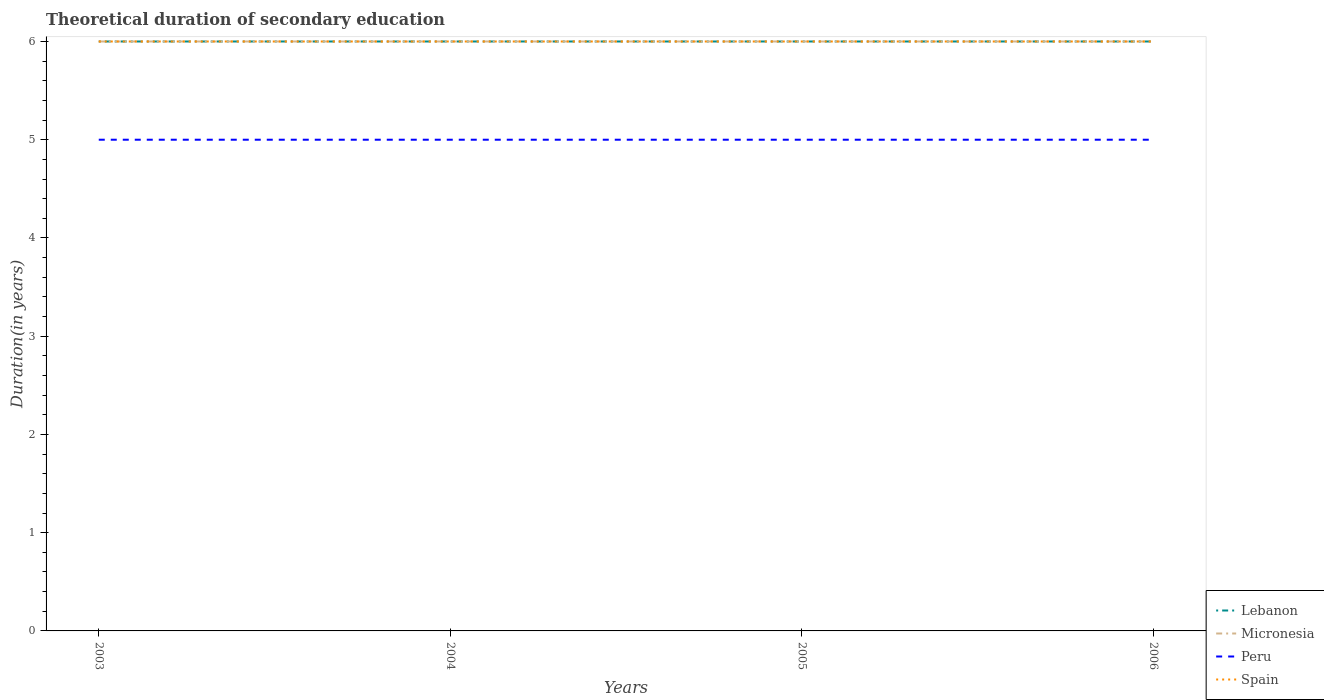Is the number of lines equal to the number of legend labels?
Provide a succinct answer. Yes. In which year was the total theoretical duration of secondary education in Spain maximum?
Your answer should be very brief. 2003. What is the difference between the highest and the lowest total theoretical duration of secondary education in Peru?
Your response must be concise. 0. Is the total theoretical duration of secondary education in Micronesia strictly greater than the total theoretical duration of secondary education in Lebanon over the years?
Offer a terse response. No. What is the difference between two consecutive major ticks on the Y-axis?
Offer a terse response. 1. Does the graph contain any zero values?
Give a very brief answer. No. What is the title of the graph?
Offer a very short reply. Theoretical duration of secondary education. What is the label or title of the X-axis?
Your answer should be very brief. Years. What is the label or title of the Y-axis?
Your answer should be very brief. Duration(in years). What is the Duration(in years) in Lebanon in 2003?
Ensure brevity in your answer.  6. What is the Duration(in years) in Micronesia in 2003?
Keep it short and to the point. 6. What is the Duration(in years) of Micronesia in 2004?
Keep it short and to the point. 6. What is the Duration(in years) in Spain in 2004?
Provide a short and direct response. 6. What is the Duration(in years) in Micronesia in 2005?
Your response must be concise. 6. What is the Duration(in years) of Peru in 2005?
Give a very brief answer. 5. What is the Duration(in years) in Spain in 2005?
Provide a succinct answer. 6. What is the Duration(in years) of Spain in 2006?
Keep it short and to the point. 6. Across all years, what is the maximum Duration(in years) of Lebanon?
Your answer should be compact. 6. Across all years, what is the maximum Duration(in years) of Spain?
Ensure brevity in your answer.  6. Across all years, what is the minimum Duration(in years) of Lebanon?
Provide a short and direct response. 6. Across all years, what is the minimum Duration(in years) of Micronesia?
Provide a short and direct response. 6. Across all years, what is the minimum Duration(in years) of Spain?
Give a very brief answer. 6. What is the total Duration(in years) of Spain in the graph?
Provide a succinct answer. 24. What is the difference between the Duration(in years) in Lebanon in 2003 and that in 2005?
Provide a short and direct response. 0. What is the difference between the Duration(in years) of Peru in 2003 and that in 2005?
Provide a short and direct response. 0. What is the difference between the Duration(in years) in Lebanon in 2003 and that in 2006?
Give a very brief answer. 0. What is the difference between the Duration(in years) in Micronesia in 2003 and that in 2006?
Keep it short and to the point. 0. What is the difference between the Duration(in years) of Peru in 2003 and that in 2006?
Offer a terse response. 0. What is the difference between the Duration(in years) of Spain in 2004 and that in 2005?
Make the answer very short. 0. What is the difference between the Duration(in years) of Lebanon in 2004 and that in 2006?
Your response must be concise. 0. What is the difference between the Duration(in years) in Micronesia in 2004 and that in 2006?
Your answer should be compact. 0. What is the difference between the Duration(in years) in Lebanon in 2005 and that in 2006?
Your answer should be compact. 0. What is the difference between the Duration(in years) in Micronesia in 2005 and that in 2006?
Your response must be concise. 0. What is the difference between the Duration(in years) in Peru in 2005 and that in 2006?
Your answer should be compact. 0. What is the difference between the Duration(in years) of Lebanon in 2003 and the Duration(in years) of Peru in 2004?
Offer a terse response. 1. What is the difference between the Duration(in years) in Micronesia in 2003 and the Duration(in years) in Spain in 2004?
Offer a very short reply. 0. What is the difference between the Duration(in years) in Lebanon in 2003 and the Duration(in years) in Spain in 2005?
Give a very brief answer. 0. What is the difference between the Duration(in years) of Micronesia in 2003 and the Duration(in years) of Peru in 2005?
Your answer should be very brief. 1. What is the difference between the Duration(in years) of Peru in 2003 and the Duration(in years) of Spain in 2005?
Your answer should be compact. -1. What is the difference between the Duration(in years) in Lebanon in 2003 and the Duration(in years) in Micronesia in 2006?
Offer a terse response. 0. What is the difference between the Duration(in years) in Lebanon in 2003 and the Duration(in years) in Peru in 2006?
Make the answer very short. 1. What is the difference between the Duration(in years) of Micronesia in 2003 and the Duration(in years) of Spain in 2006?
Your answer should be compact. 0. What is the difference between the Duration(in years) of Lebanon in 2004 and the Duration(in years) of Peru in 2005?
Keep it short and to the point. 1. What is the difference between the Duration(in years) in Micronesia in 2004 and the Duration(in years) in Peru in 2005?
Offer a terse response. 1. What is the difference between the Duration(in years) in Micronesia in 2004 and the Duration(in years) in Spain in 2005?
Provide a short and direct response. 0. What is the difference between the Duration(in years) in Lebanon in 2004 and the Duration(in years) in Micronesia in 2006?
Keep it short and to the point. 0. What is the difference between the Duration(in years) of Lebanon in 2004 and the Duration(in years) of Spain in 2006?
Keep it short and to the point. 0. What is the difference between the Duration(in years) in Micronesia in 2004 and the Duration(in years) in Peru in 2006?
Provide a short and direct response. 1. What is the difference between the Duration(in years) in Micronesia in 2004 and the Duration(in years) in Spain in 2006?
Your answer should be compact. 0. What is the difference between the Duration(in years) of Lebanon in 2005 and the Duration(in years) of Micronesia in 2006?
Your response must be concise. 0. What is the difference between the Duration(in years) of Lebanon in 2005 and the Duration(in years) of Peru in 2006?
Ensure brevity in your answer.  1. What is the difference between the Duration(in years) of Micronesia in 2005 and the Duration(in years) of Peru in 2006?
Your answer should be compact. 1. What is the difference between the Duration(in years) of Peru in 2005 and the Duration(in years) of Spain in 2006?
Your answer should be compact. -1. What is the average Duration(in years) in Lebanon per year?
Offer a very short reply. 6. What is the average Duration(in years) in Peru per year?
Provide a succinct answer. 5. What is the average Duration(in years) in Spain per year?
Your answer should be compact. 6. In the year 2003, what is the difference between the Duration(in years) in Lebanon and Duration(in years) in Micronesia?
Give a very brief answer. 0. In the year 2003, what is the difference between the Duration(in years) of Lebanon and Duration(in years) of Peru?
Make the answer very short. 1. In the year 2003, what is the difference between the Duration(in years) in Lebanon and Duration(in years) in Spain?
Provide a short and direct response. 0. In the year 2003, what is the difference between the Duration(in years) of Peru and Duration(in years) of Spain?
Keep it short and to the point. -1. In the year 2004, what is the difference between the Duration(in years) in Lebanon and Duration(in years) in Micronesia?
Keep it short and to the point. 0. In the year 2004, what is the difference between the Duration(in years) of Lebanon and Duration(in years) of Peru?
Make the answer very short. 1. In the year 2004, what is the difference between the Duration(in years) of Lebanon and Duration(in years) of Spain?
Give a very brief answer. 0. In the year 2004, what is the difference between the Duration(in years) of Micronesia and Duration(in years) of Spain?
Keep it short and to the point. 0. In the year 2004, what is the difference between the Duration(in years) in Peru and Duration(in years) in Spain?
Offer a very short reply. -1. In the year 2005, what is the difference between the Duration(in years) in Lebanon and Duration(in years) in Spain?
Offer a very short reply. 0. In the year 2005, what is the difference between the Duration(in years) of Micronesia and Duration(in years) of Spain?
Ensure brevity in your answer.  0. In the year 2005, what is the difference between the Duration(in years) in Peru and Duration(in years) in Spain?
Make the answer very short. -1. In the year 2006, what is the difference between the Duration(in years) in Micronesia and Duration(in years) in Peru?
Your answer should be very brief. 1. In the year 2006, what is the difference between the Duration(in years) in Peru and Duration(in years) in Spain?
Provide a short and direct response. -1. What is the ratio of the Duration(in years) of Lebanon in 2003 to that in 2004?
Your answer should be very brief. 1. What is the ratio of the Duration(in years) of Spain in 2003 to that in 2004?
Your response must be concise. 1. What is the ratio of the Duration(in years) of Lebanon in 2003 to that in 2005?
Give a very brief answer. 1. What is the ratio of the Duration(in years) of Peru in 2003 to that in 2005?
Give a very brief answer. 1. What is the ratio of the Duration(in years) in Lebanon in 2003 to that in 2006?
Give a very brief answer. 1. What is the ratio of the Duration(in years) of Micronesia in 2003 to that in 2006?
Your answer should be compact. 1. What is the ratio of the Duration(in years) of Peru in 2003 to that in 2006?
Offer a terse response. 1. What is the ratio of the Duration(in years) in Lebanon in 2004 to that in 2005?
Give a very brief answer. 1. What is the ratio of the Duration(in years) in Micronesia in 2004 to that in 2005?
Keep it short and to the point. 1. What is the ratio of the Duration(in years) in Peru in 2004 to that in 2005?
Keep it short and to the point. 1. What is the ratio of the Duration(in years) of Spain in 2004 to that in 2005?
Offer a terse response. 1. What is the ratio of the Duration(in years) of Lebanon in 2004 to that in 2006?
Give a very brief answer. 1. What is the ratio of the Duration(in years) of Micronesia in 2005 to that in 2006?
Ensure brevity in your answer.  1. What is the ratio of the Duration(in years) in Spain in 2005 to that in 2006?
Your answer should be very brief. 1. What is the difference between the highest and the second highest Duration(in years) of Lebanon?
Offer a terse response. 0. What is the difference between the highest and the second highest Duration(in years) of Peru?
Make the answer very short. 0. What is the difference between the highest and the lowest Duration(in years) in Lebanon?
Give a very brief answer. 0. What is the difference between the highest and the lowest Duration(in years) in Peru?
Provide a short and direct response. 0. 